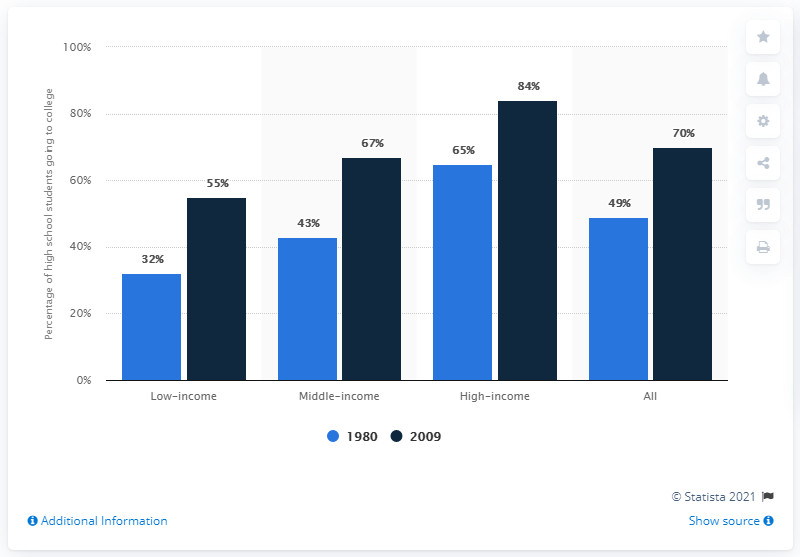Identify some key points in this picture. In 2009, the difference between low-income and middle-income students attending college was significant, with low-income students facing unique challenges and disadvantages in accessing and succeeding in higher education. In 1980, a high school student who planned to attend college had a high income of 65%. 